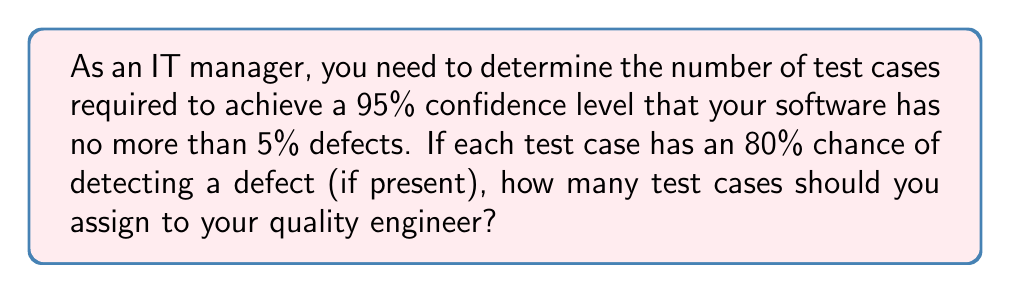Provide a solution to this math problem. To solve this problem, we'll use the following approach:

1. Define the variables:
   $p$ = probability of a defect (5% or 0.05)
   $c$ = confidence level (95% or 0.95)
   $d$ = defect detection rate (80% or 0.8)
   $n$ = number of test cases needed

2. Use the formula for confidence level in terms of test cases:
   $c = 1 - (1 - pd)^n$

3. Substitute the known values:
   $0.95 = 1 - (1 - 0.05 * 0.8)^n$

4. Simplify:
   $0.95 = 1 - (0.96)^n$

5. Solve for $n$:
   $0.05 = (0.96)^n$
   $\ln(0.05) = n \ln(0.96)$
   $n = \frac{\ln(0.05)}{\ln(0.96)}$

6. Calculate the result:
   $n \approx 73.97$

7. Round up to the nearest whole number:
   $n = 74$

Therefore, you should assign 74 test cases to your quality engineer to achieve the desired confidence level.
Answer: 74 test cases 